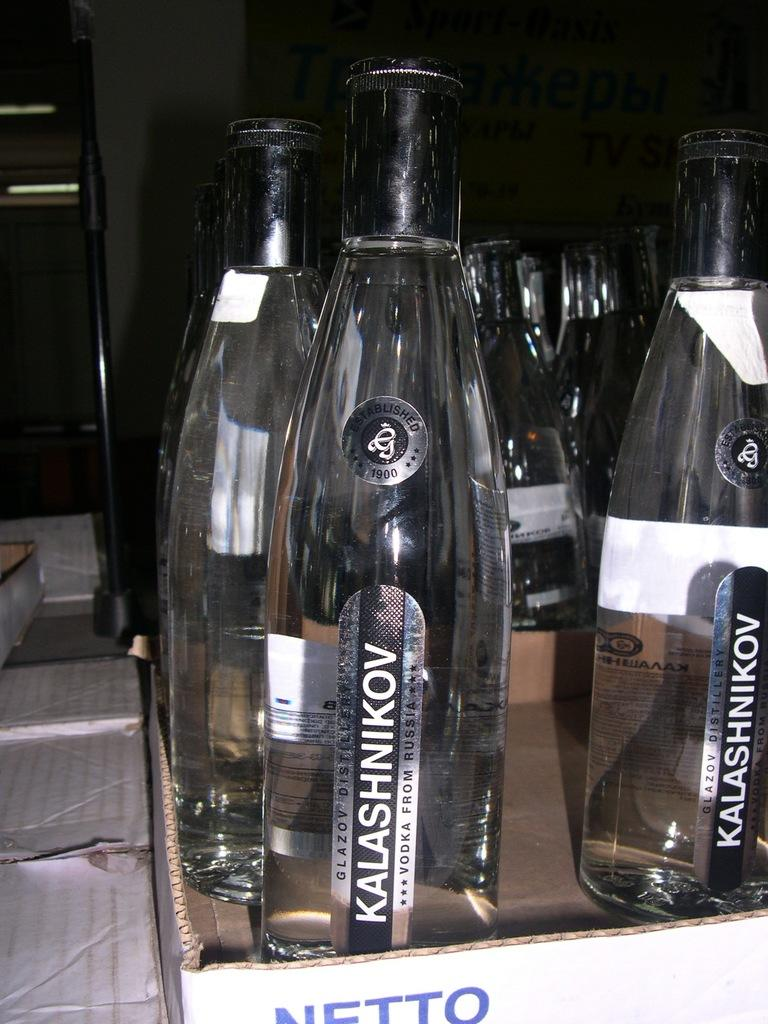<image>
Create a compact narrative representing the image presented. A row of Kalashnikov alcohol from Russia are waiting to be served. 